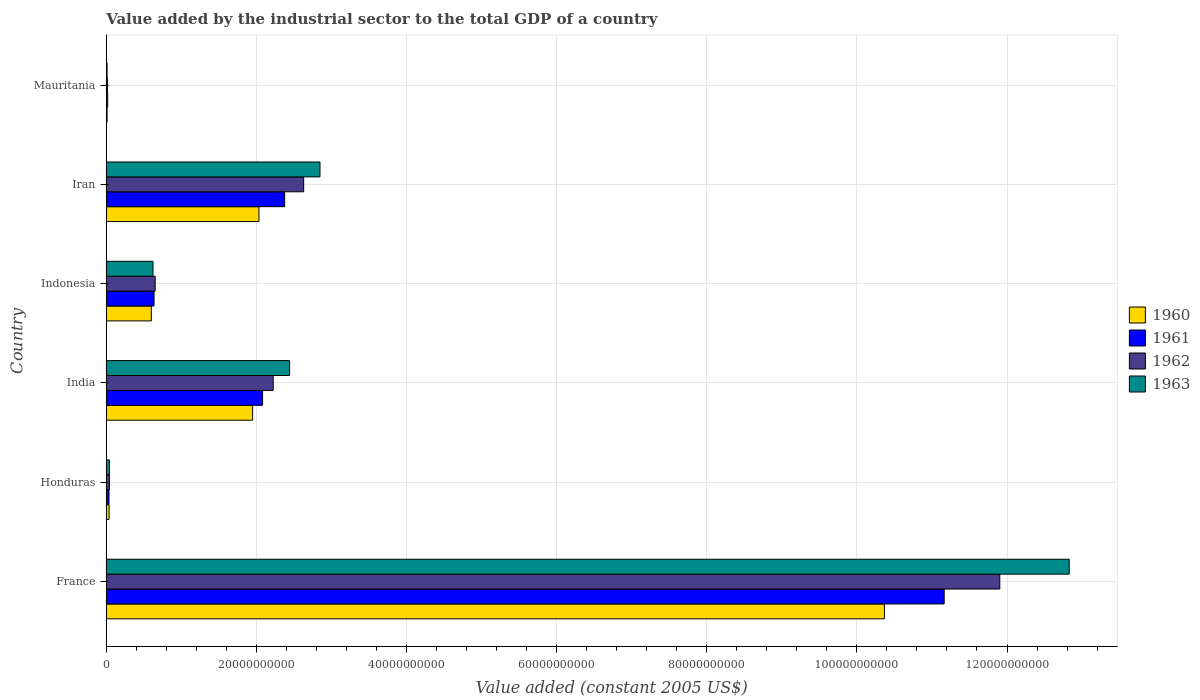Are the number of bars on each tick of the Y-axis equal?
Give a very brief answer. Yes. What is the label of the 2nd group of bars from the top?
Your answer should be very brief. Iran. What is the value added by the industrial sector in 1963 in Honduras?
Offer a terse response. 4.23e+08. Across all countries, what is the maximum value added by the industrial sector in 1963?
Give a very brief answer. 1.28e+11. Across all countries, what is the minimum value added by the industrial sector in 1961?
Offer a terse response. 1.92e+08. In which country was the value added by the industrial sector in 1963 minimum?
Make the answer very short. Mauritania. What is the total value added by the industrial sector in 1963 in the graph?
Ensure brevity in your answer.  1.88e+11. What is the difference between the value added by the industrial sector in 1963 in Honduras and that in Iran?
Offer a terse response. -2.81e+1. What is the difference between the value added by the industrial sector in 1963 in India and the value added by the industrial sector in 1960 in France?
Ensure brevity in your answer.  -7.92e+1. What is the average value added by the industrial sector in 1963 per country?
Your response must be concise. 3.13e+1. What is the difference between the value added by the industrial sector in 1962 and value added by the industrial sector in 1960 in Indonesia?
Offer a terse response. 5.10e+08. In how many countries, is the value added by the industrial sector in 1962 greater than 72000000000 US$?
Your answer should be compact. 1. What is the ratio of the value added by the industrial sector in 1963 in Honduras to that in Mauritania?
Your response must be concise. 3.91. Is the difference between the value added by the industrial sector in 1962 in France and India greater than the difference between the value added by the industrial sector in 1960 in France and India?
Make the answer very short. Yes. What is the difference between the highest and the second highest value added by the industrial sector in 1961?
Provide a succinct answer. 8.79e+1. What is the difference between the highest and the lowest value added by the industrial sector in 1960?
Offer a terse response. 1.04e+11. What does the 4th bar from the top in Iran represents?
Give a very brief answer. 1960. Are all the bars in the graph horizontal?
Provide a succinct answer. Yes. How many legend labels are there?
Provide a short and direct response. 4. What is the title of the graph?
Keep it short and to the point. Value added by the industrial sector to the total GDP of a country. What is the label or title of the X-axis?
Give a very brief answer. Value added (constant 2005 US$). What is the Value added (constant 2005 US$) in 1960 in France?
Offer a terse response. 1.04e+11. What is the Value added (constant 2005 US$) in 1961 in France?
Offer a terse response. 1.12e+11. What is the Value added (constant 2005 US$) of 1962 in France?
Keep it short and to the point. 1.19e+11. What is the Value added (constant 2005 US$) of 1963 in France?
Keep it short and to the point. 1.28e+11. What is the Value added (constant 2005 US$) in 1960 in Honduras?
Provide a succinct answer. 3.75e+08. What is the Value added (constant 2005 US$) in 1961 in Honduras?
Ensure brevity in your answer.  3.66e+08. What is the Value added (constant 2005 US$) in 1962 in Honduras?
Keep it short and to the point. 4.16e+08. What is the Value added (constant 2005 US$) of 1963 in Honduras?
Give a very brief answer. 4.23e+08. What is the Value added (constant 2005 US$) of 1960 in India?
Keep it short and to the point. 1.95e+1. What is the Value added (constant 2005 US$) in 1961 in India?
Your response must be concise. 2.08e+1. What is the Value added (constant 2005 US$) of 1962 in India?
Your response must be concise. 2.22e+1. What is the Value added (constant 2005 US$) in 1963 in India?
Make the answer very short. 2.44e+1. What is the Value added (constant 2005 US$) in 1960 in Indonesia?
Your response must be concise. 6.01e+09. What is the Value added (constant 2005 US$) of 1961 in Indonesia?
Provide a short and direct response. 6.37e+09. What is the Value added (constant 2005 US$) in 1962 in Indonesia?
Make the answer very short. 6.52e+09. What is the Value added (constant 2005 US$) of 1963 in Indonesia?
Make the answer very short. 6.23e+09. What is the Value added (constant 2005 US$) of 1960 in Iran?
Provide a short and direct response. 2.03e+1. What is the Value added (constant 2005 US$) of 1961 in Iran?
Keep it short and to the point. 2.38e+1. What is the Value added (constant 2005 US$) in 1962 in Iran?
Offer a terse response. 2.63e+1. What is the Value added (constant 2005 US$) of 1963 in Iran?
Make the answer very short. 2.85e+1. What is the Value added (constant 2005 US$) of 1960 in Mauritania?
Ensure brevity in your answer.  1.15e+08. What is the Value added (constant 2005 US$) of 1961 in Mauritania?
Your answer should be very brief. 1.92e+08. What is the Value added (constant 2005 US$) of 1962 in Mauritania?
Ensure brevity in your answer.  1.51e+08. What is the Value added (constant 2005 US$) in 1963 in Mauritania?
Your response must be concise. 1.08e+08. Across all countries, what is the maximum Value added (constant 2005 US$) of 1960?
Your answer should be compact. 1.04e+11. Across all countries, what is the maximum Value added (constant 2005 US$) of 1961?
Your answer should be very brief. 1.12e+11. Across all countries, what is the maximum Value added (constant 2005 US$) in 1962?
Provide a succinct answer. 1.19e+11. Across all countries, what is the maximum Value added (constant 2005 US$) of 1963?
Your answer should be very brief. 1.28e+11. Across all countries, what is the minimum Value added (constant 2005 US$) of 1960?
Provide a succinct answer. 1.15e+08. Across all countries, what is the minimum Value added (constant 2005 US$) of 1961?
Keep it short and to the point. 1.92e+08. Across all countries, what is the minimum Value added (constant 2005 US$) of 1962?
Your response must be concise. 1.51e+08. Across all countries, what is the minimum Value added (constant 2005 US$) of 1963?
Offer a terse response. 1.08e+08. What is the total Value added (constant 2005 US$) in 1960 in the graph?
Provide a succinct answer. 1.50e+11. What is the total Value added (constant 2005 US$) in 1961 in the graph?
Provide a short and direct response. 1.63e+11. What is the total Value added (constant 2005 US$) of 1962 in the graph?
Make the answer very short. 1.75e+11. What is the total Value added (constant 2005 US$) in 1963 in the graph?
Offer a terse response. 1.88e+11. What is the difference between the Value added (constant 2005 US$) in 1960 in France and that in Honduras?
Make the answer very short. 1.03e+11. What is the difference between the Value added (constant 2005 US$) of 1961 in France and that in Honduras?
Your response must be concise. 1.11e+11. What is the difference between the Value added (constant 2005 US$) of 1962 in France and that in Honduras?
Your answer should be compact. 1.19e+11. What is the difference between the Value added (constant 2005 US$) in 1963 in France and that in Honduras?
Your answer should be compact. 1.28e+11. What is the difference between the Value added (constant 2005 US$) of 1960 in France and that in India?
Make the answer very short. 8.42e+1. What is the difference between the Value added (constant 2005 US$) of 1961 in France and that in India?
Your response must be concise. 9.08e+1. What is the difference between the Value added (constant 2005 US$) in 1962 in France and that in India?
Your answer should be very brief. 9.68e+1. What is the difference between the Value added (constant 2005 US$) in 1963 in France and that in India?
Provide a succinct answer. 1.04e+11. What is the difference between the Value added (constant 2005 US$) in 1960 in France and that in Indonesia?
Offer a terse response. 9.77e+1. What is the difference between the Value added (constant 2005 US$) in 1961 in France and that in Indonesia?
Provide a short and direct response. 1.05e+11. What is the difference between the Value added (constant 2005 US$) of 1962 in France and that in Indonesia?
Give a very brief answer. 1.13e+11. What is the difference between the Value added (constant 2005 US$) in 1963 in France and that in Indonesia?
Provide a succinct answer. 1.22e+11. What is the difference between the Value added (constant 2005 US$) of 1960 in France and that in Iran?
Give a very brief answer. 8.33e+1. What is the difference between the Value added (constant 2005 US$) in 1961 in France and that in Iran?
Make the answer very short. 8.79e+1. What is the difference between the Value added (constant 2005 US$) in 1962 in France and that in Iran?
Your response must be concise. 9.27e+1. What is the difference between the Value added (constant 2005 US$) in 1963 in France and that in Iran?
Ensure brevity in your answer.  9.98e+1. What is the difference between the Value added (constant 2005 US$) of 1960 in France and that in Mauritania?
Your answer should be very brief. 1.04e+11. What is the difference between the Value added (constant 2005 US$) in 1961 in France and that in Mauritania?
Give a very brief answer. 1.11e+11. What is the difference between the Value added (constant 2005 US$) of 1962 in France and that in Mauritania?
Your response must be concise. 1.19e+11. What is the difference between the Value added (constant 2005 US$) of 1963 in France and that in Mauritania?
Your response must be concise. 1.28e+11. What is the difference between the Value added (constant 2005 US$) in 1960 in Honduras and that in India?
Make the answer very short. -1.91e+1. What is the difference between the Value added (constant 2005 US$) of 1961 in Honduras and that in India?
Give a very brief answer. -2.05e+1. What is the difference between the Value added (constant 2005 US$) in 1962 in Honduras and that in India?
Provide a short and direct response. -2.18e+1. What is the difference between the Value added (constant 2005 US$) of 1963 in Honduras and that in India?
Keep it short and to the point. -2.40e+1. What is the difference between the Value added (constant 2005 US$) in 1960 in Honduras and that in Indonesia?
Make the answer very short. -5.63e+09. What is the difference between the Value added (constant 2005 US$) of 1961 in Honduras and that in Indonesia?
Offer a terse response. -6.00e+09. What is the difference between the Value added (constant 2005 US$) in 1962 in Honduras and that in Indonesia?
Make the answer very short. -6.10e+09. What is the difference between the Value added (constant 2005 US$) of 1963 in Honduras and that in Indonesia?
Give a very brief answer. -5.81e+09. What is the difference between the Value added (constant 2005 US$) in 1960 in Honduras and that in Iran?
Provide a short and direct response. -2.00e+1. What is the difference between the Value added (constant 2005 US$) in 1961 in Honduras and that in Iran?
Provide a succinct answer. -2.34e+1. What is the difference between the Value added (constant 2005 US$) of 1962 in Honduras and that in Iran?
Keep it short and to the point. -2.59e+1. What is the difference between the Value added (constant 2005 US$) in 1963 in Honduras and that in Iran?
Provide a short and direct response. -2.81e+1. What is the difference between the Value added (constant 2005 US$) of 1960 in Honduras and that in Mauritania?
Ensure brevity in your answer.  2.60e+08. What is the difference between the Value added (constant 2005 US$) of 1961 in Honduras and that in Mauritania?
Provide a succinct answer. 1.74e+08. What is the difference between the Value added (constant 2005 US$) of 1962 in Honduras and that in Mauritania?
Ensure brevity in your answer.  2.65e+08. What is the difference between the Value added (constant 2005 US$) of 1963 in Honduras and that in Mauritania?
Your answer should be compact. 3.15e+08. What is the difference between the Value added (constant 2005 US$) of 1960 in India and that in Indonesia?
Offer a very short reply. 1.35e+1. What is the difference between the Value added (constant 2005 US$) of 1961 in India and that in Indonesia?
Make the answer very short. 1.45e+1. What is the difference between the Value added (constant 2005 US$) in 1962 in India and that in Indonesia?
Give a very brief answer. 1.57e+1. What is the difference between the Value added (constant 2005 US$) in 1963 in India and that in Indonesia?
Your response must be concise. 1.82e+1. What is the difference between the Value added (constant 2005 US$) in 1960 in India and that in Iran?
Ensure brevity in your answer.  -8.36e+08. What is the difference between the Value added (constant 2005 US$) of 1961 in India and that in Iran?
Give a very brief answer. -2.94e+09. What is the difference between the Value added (constant 2005 US$) of 1962 in India and that in Iran?
Your answer should be compact. -4.06e+09. What is the difference between the Value added (constant 2005 US$) in 1963 in India and that in Iran?
Offer a very short reply. -4.05e+09. What is the difference between the Value added (constant 2005 US$) in 1960 in India and that in Mauritania?
Your answer should be very brief. 1.94e+1. What is the difference between the Value added (constant 2005 US$) in 1961 in India and that in Mauritania?
Provide a succinct answer. 2.06e+1. What is the difference between the Value added (constant 2005 US$) in 1962 in India and that in Mauritania?
Your response must be concise. 2.21e+1. What is the difference between the Value added (constant 2005 US$) in 1963 in India and that in Mauritania?
Ensure brevity in your answer.  2.43e+1. What is the difference between the Value added (constant 2005 US$) of 1960 in Indonesia and that in Iran?
Give a very brief answer. -1.43e+1. What is the difference between the Value added (constant 2005 US$) of 1961 in Indonesia and that in Iran?
Ensure brevity in your answer.  -1.74e+1. What is the difference between the Value added (constant 2005 US$) of 1962 in Indonesia and that in Iran?
Keep it short and to the point. -1.98e+1. What is the difference between the Value added (constant 2005 US$) in 1963 in Indonesia and that in Iran?
Your answer should be very brief. -2.22e+1. What is the difference between the Value added (constant 2005 US$) in 1960 in Indonesia and that in Mauritania?
Keep it short and to the point. 5.89e+09. What is the difference between the Value added (constant 2005 US$) of 1961 in Indonesia and that in Mauritania?
Offer a terse response. 6.17e+09. What is the difference between the Value added (constant 2005 US$) in 1962 in Indonesia and that in Mauritania?
Make the answer very short. 6.37e+09. What is the difference between the Value added (constant 2005 US$) in 1963 in Indonesia and that in Mauritania?
Give a very brief answer. 6.12e+09. What is the difference between the Value added (constant 2005 US$) in 1960 in Iran and that in Mauritania?
Your answer should be very brief. 2.02e+1. What is the difference between the Value added (constant 2005 US$) of 1961 in Iran and that in Mauritania?
Your answer should be compact. 2.36e+1. What is the difference between the Value added (constant 2005 US$) of 1962 in Iran and that in Mauritania?
Offer a very short reply. 2.62e+1. What is the difference between the Value added (constant 2005 US$) of 1963 in Iran and that in Mauritania?
Provide a succinct answer. 2.84e+1. What is the difference between the Value added (constant 2005 US$) in 1960 in France and the Value added (constant 2005 US$) in 1961 in Honduras?
Offer a terse response. 1.03e+11. What is the difference between the Value added (constant 2005 US$) in 1960 in France and the Value added (constant 2005 US$) in 1962 in Honduras?
Offer a terse response. 1.03e+11. What is the difference between the Value added (constant 2005 US$) of 1960 in France and the Value added (constant 2005 US$) of 1963 in Honduras?
Your answer should be compact. 1.03e+11. What is the difference between the Value added (constant 2005 US$) in 1961 in France and the Value added (constant 2005 US$) in 1962 in Honduras?
Ensure brevity in your answer.  1.11e+11. What is the difference between the Value added (constant 2005 US$) of 1961 in France and the Value added (constant 2005 US$) of 1963 in Honduras?
Your answer should be compact. 1.11e+11. What is the difference between the Value added (constant 2005 US$) in 1962 in France and the Value added (constant 2005 US$) in 1963 in Honduras?
Keep it short and to the point. 1.19e+11. What is the difference between the Value added (constant 2005 US$) in 1960 in France and the Value added (constant 2005 US$) in 1961 in India?
Offer a terse response. 8.28e+1. What is the difference between the Value added (constant 2005 US$) of 1960 in France and the Value added (constant 2005 US$) of 1962 in India?
Your response must be concise. 8.14e+1. What is the difference between the Value added (constant 2005 US$) in 1960 in France and the Value added (constant 2005 US$) in 1963 in India?
Provide a short and direct response. 7.92e+1. What is the difference between the Value added (constant 2005 US$) of 1961 in France and the Value added (constant 2005 US$) of 1962 in India?
Offer a terse response. 8.94e+1. What is the difference between the Value added (constant 2005 US$) in 1961 in France and the Value added (constant 2005 US$) in 1963 in India?
Provide a succinct answer. 8.72e+1. What is the difference between the Value added (constant 2005 US$) in 1962 in France and the Value added (constant 2005 US$) in 1963 in India?
Provide a short and direct response. 9.46e+1. What is the difference between the Value added (constant 2005 US$) in 1960 in France and the Value added (constant 2005 US$) in 1961 in Indonesia?
Ensure brevity in your answer.  9.73e+1. What is the difference between the Value added (constant 2005 US$) of 1960 in France and the Value added (constant 2005 US$) of 1962 in Indonesia?
Keep it short and to the point. 9.71e+1. What is the difference between the Value added (constant 2005 US$) in 1960 in France and the Value added (constant 2005 US$) in 1963 in Indonesia?
Your answer should be very brief. 9.74e+1. What is the difference between the Value added (constant 2005 US$) in 1961 in France and the Value added (constant 2005 US$) in 1962 in Indonesia?
Your answer should be compact. 1.05e+11. What is the difference between the Value added (constant 2005 US$) in 1961 in France and the Value added (constant 2005 US$) in 1963 in Indonesia?
Offer a terse response. 1.05e+11. What is the difference between the Value added (constant 2005 US$) in 1962 in France and the Value added (constant 2005 US$) in 1963 in Indonesia?
Provide a succinct answer. 1.13e+11. What is the difference between the Value added (constant 2005 US$) in 1960 in France and the Value added (constant 2005 US$) in 1961 in Iran?
Provide a succinct answer. 7.99e+1. What is the difference between the Value added (constant 2005 US$) of 1960 in France and the Value added (constant 2005 US$) of 1962 in Iran?
Provide a succinct answer. 7.74e+1. What is the difference between the Value added (constant 2005 US$) of 1960 in France and the Value added (constant 2005 US$) of 1963 in Iran?
Provide a succinct answer. 7.52e+1. What is the difference between the Value added (constant 2005 US$) of 1961 in France and the Value added (constant 2005 US$) of 1962 in Iran?
Ensure brevity in your answer.  8.53e+1. What is the difference between the Value added (constant 2005 US$) of 1961 in France and the Value added (constant 2005 US$) of 1963 in Iran?
Your answer should be compact. 8.32e+1. What is the difference between the Value added (constant 2005 US$) of 1962 in France and the Value added (constant 2005 US$) of 1963 in Iran?
Your response must be concise. 9.06e+1. What is the difference between the Value added (constant 2005 US$) of 1960 in France and the Value added (constant 2005 US$) of 1961 in Mauritania?
Your answer should be compact. 1.03e+11. What is the difference between the Value added (constant 2005 US$) of 1960 in France and the Value added (constant 2005 US$) of 1962 in Mauritania?
Offer a terse response. 1.04e+11. What is the difference between the Value added (constant 2005 US$) in 1960 in France and the Value added (constant 2005 US$) in 1963 in Mauritania?
Offer a very short reply. 1.04e+11. What is the difference between the Value added (constant 2005 US$) of 1961 in France and the Value added (constant 2005 US$) of 1962 in Mauritania?
Provide a succinct answer. 1.11e+11. What is the difference between the Value added (constant 2005 US$) in 1961 in France and the Value added (constant 2005 US$) in 1963 in Mauritania?
Your response must be concise. 1.12e+11. What is the difference between the Value added (constant 2005 US$) of 1962 in France and the Value added (constant 2005 US$) of 1963 in Mauritania?
Provide a short and direct response. 1.19e+11. What is the difference between the Value added (constant 2005 US$) in 1960 in Honduras and the Value added (constant 2005 US$) in 1961 in India?
Make the answer very short. -2.05e+1. What is the difference between the Value added (constant 2005 US$) of 1960 in Honduras and the Value added (constant 2005 US$) of 1962 in India?
Provide a short and direct response. -2.19e+1. What is the difference between the Value added (constant 2005 US$) of 1960 in Honduras and the Value added (constant 2005 US$) of 1963 in India?
Make the answer very short. -2.41e+1. What is the difference between the Value added (constant 2005 US$) in 1961 in Honduras and the Value added (constant 2005 US$) in 1962 in India?
Offer a very short reply. -2.19e+1. What is the difference between the Value added (constant 2005 US$) of 1961 in Honduras and the Value added (constant 2005 US$) of 1963 in India?
Offer a terse response. -2.41e+1. What is the difference between the Value added (constant 2005 US$) of 1962 in Honduras and the Value added (constant 2005 US$) of 1963 in India?
Ensure brevity in your answer.  -2.40e+1. What is the difference between the Value added (constant 2005 US$) of 1960 in Honduras and the Value added (constant 2005 US$) of 1961 in Indonesia?
Offer a very short reply. -5.99e+09. What is the difference between the Value added (constant 2005 US$) in 1960 in Honduras and the Value added (constant 2005 US$) in 1962 in Indonesia?
Your answer should be very brief. -6.14e+09. What is the difference between the Value added (constant 2005 US$) of 1960 in Honduras and the Value added (constant 2005 US$) of 1963 in Indonesia?
Offer a very short reply. -5.85e+09. What is the difference between the Value added (constant 2005 US$) in 1961 in Honduras and the Value added (constant 2005 US$) in 1962 in Indonesia?
Your response must be concise. -6.15e+09. What is the difference between the Value added (constant 2005 US$) of 1961 in Honduras and the Value added (constant 2005 US$) of 1963 in Indonesia?
Offer a terse response. -5.86e+09. What is the difference between the Value added (constant 2005 US$) in 1962 in Honduras and the Value added (constant 2005 US$) in 1963 in Indonesia?
Offer a very short reply. -5.81e+09. What is the difference between the Value added (constant 2005 US$) of 1960 in Honduras and the Value added (constant 2005 US$) of 1961 in Iran?
Your response must be concise. -2.34e+1. What is the difference between the Value added (constant 2005 US$) in 1960 in Honduras and the Value added (constant 2005 US$) in 1962 in Iran?
Give a very brief answer. -2.59e+1. What is the difference between the Value added (constant 2005 US$) in 1960 in Honduras and the Value added (constant 2005 US$) in 1963 in Iran?
Give a very brief answer. -2.81e+1. What is the difference between the Value added (constant 2005 US$) in 1961 in Honduras and the Value added (constant 2005 US$) in 1962 in Iran?
Give a very brief answer. -2.59e+1. What is the difference between the Value added (constant 2005 US$) of 1961 in Honduras and the Value added (constant 2005 US$) of 1963 in Iran?
Keep it short and to the point. -2.81e+1. What is the difference between the Value added (constant 2005 US$) of 1962 in Honduras and the Value added (constant 2005 US$) of 1963 in Iran?
Ensure brevity in your answer.  -2.81e+1. What is the difference between the Value added (constant 2005 US$) of 1960 in Honduras and the Value added (constant 2005 US$) of 1961 in Mauritania?
Make the answer very short. 1.83e+08. What is the difference between the Value added (constant 2005 US$) of 1960 in Honduras and the Value added (constant 2005 US$) of 1962 in Mauritania?
Provide a short and direct response. 2.24e+08. What is the difference between the Value added (constant 2005 US$) of 1960 in Honduras and the Value added (constant 2005 US$) of 1963 in Mauritania?
Your response must be concise. 2.67e+08. What is the difference between the Value added (constant 2005 US$) in 1961 in Honduras and the Value added (constant 2005 US$) in 1962 in Mauritania?
Provide a succinct answer. 2.15e+08. What is the difference between the Value added (constant 2005 US$) of 1961 in Honduras and the Value added (constant 2005 US$) of 1963 in Mauritania?
Keep it short and to the point. 2.58e+08. What is the difference between the Value added (constant 2005 US$) in 1962 in Honduras and the Value added (constant 2005 US$) in 1963 in Mauritania?
Your answer should be very brief. 3.08e+08. What is the difference between the Value added (constant 2005 US$) of 1960 in India and the Value added (constant 2005 US$) of 1961 in Indonesia?
Give a very brief answer. 1.31e+1. What is the difference between the Value added (constant 2005 US$) of 1960 in India and the Value added (constant 2005 US$) of 1962 in Indonesia?
Your answer should be compact. 1.30e+1. What is the difference between the Value added (constant 2005 US$) of 1960 in India and the Value added (constant 2005 US$) of 1963 in Indonesia?
Give a very brief answer. 1.33e+1. What is the difference between the Value added (constant 2005 US$) of 1961 in India and the Value added (constant 2005 US$) of 1962 in Indonesia?
Make the answer very short. 1.43e+1. What is the difference between the Value added (constant 2005 US$) in 1961 in India and the Value added (constant 2005 US$) in 1963 in Indonesia?
Offer a terse response. 1.46e+1. What is the difference between the Value added (constant 2005 US$) of 1962 in India and the Value added (constant 2005 US$) of 1963 in Indonesia?
Provide a short and direct response. 1.60e+1. What is the difference between the Value added (constant 2005 US$) in 1960 in India and the Value added (constant 2005 US$) in 1961 in Iran?
Offer a terse response. -4.27e+09. What is the difference between the Value added (constant 2005 US$) in 1960 in India and the Value added (constant 2005 US$) in 1962 in Iran?
Provide a succinct answer. -6.80e+09. What is the difference between the Value added (constant 2005 US$) of 1960 in India and the Value added (constant 2005 US$) of 1963 in Iran?
Offer a terse response. -8.97e+09. What is the difference between the Value added (constant 2005 US$) of 1961 in India and the Value added (constant 2005 US$) of 1962 in Iran?
Make the answer very short. -5.48e+09. What is the difference between the Value added (constant 2005 US$) of 1961 in India and the Value added (constant 2005 US$) of 1963 in Iran?
Your answer should be compact. -7.65e+09. What is the difference between the Value added (constant 2005 US$) of 1962 in India and the Value added (constant 2005 US$) of 1963 in Iran?
Make the answer very short. -6.23e+09. What is the difference between the Value added (constant 2005 US$) in 1960 in India and the Value added (constant 2005 US$) in 1961 in Mauritania?
Provide a succinct answer. 1.93e+1. What is the difference between the Value added (constant 2005 US$) in 1960 in India and the Value added (constant 2005 US$) in 1962 in Mauritania?
Keep it short and to the point. 1.94e+1. What is the difference between the Value added (constant 2005 US$) in 1960 in India and the Value added (constant 2005 US$) in 1963 in Mauritania?
Offer a terse response. 1.94e+1. What is the difference between the Value added (constant 2005 US$) in 1961 in India and the Value added (constant 2005 US$) in 1962 in Mauritania?
Your response must be concise. 2.07e+1. What is the difference between the Value added (constant 2005 US$) in 1961 in India and the Value added (constant 2005 US$) in 1963 in Mauritania?
Your answer should be very brief. 2.07e+1. What is the difference between the Value added (constant 2005 US$) of 1962 in India and the Value added (constant 2005 US$) of 1963 in Mauritania?
Your response must be concise. 2.21e+1. What is the difference between the Value added (constant 2005 US$) of 1960 in Indonesia and the Value added (constant 2005 US$) of 1961 in Iran?
Ensure brevity in your answer.  -1.78e+1. What is the difference between the Value added (constant 2005 US$) in 1960 in Indonesia and the Value added (constant 2005 US$) in 1962 in Iran?
Offer a very short reply. -2.03e+1. What is the difference between the Value added (constant 2005 US$) of 1960 in Indonesia and the Value added (constant 2005 US$) of 1963 in Iran?
Ensure brevity in your answer.  -2.25e+1. What is the difference between the Value added (constant 2005 US$) of 1961 in Indonesia and the Value added (constant 2005 US$) of 1962 in Iran?
Make the answer very short. -1.99e+1. What is the difference between the Value added (constant 2005 US$) of 1961 in Indonesia and the Value added (constant 2005 US$) of 1963 in Iran?
Offer a very short reply. -2.21e+1. What is the difference between the Value added (constant 2005 US$) of 1962 in Indonesia and the Value added (constant 2005 US$) of 1963 in Iran?
Offer a very short reply. -2.20e+1. What is the difference between the Value added (constant 2005 US$) in 1960 in Indonesia and the Value added (constant 2005 US$) in 1961 in Mauritania?
Offer a terse response. 5.81e+09. What is the difference between the Value added (constant 2005 US$) in 1960 in Indonesia and the Value added (constant 2005 US$) in 1962 in Mauritania?
Your answer should be very brief. 5.86e+09. What is the difference between the Value added (constant 2005 US$) of 1960 in Indonesia and the Value added (constant 2005 US$) of 1963 in Mauritania?
Provide a short and direct response. 5.90e+09. What is the difference between the Value added (constant 2005 US$) of 1961 in Indonesia and the Value added (constant 2005 US$) of 1962 in Mauritania?
Offer a very short reply. 6.22e+09. What is the difference between the Value added (constant 2005 US$) in 1961 in Indonesia and the Value added (constant 2005 US$) in 1963 in Mauritania?
Your response must be concise. 6.26e+09. What is the difference between the Value added (constant 2005 US$) in 1962 in Indonesia and the Value added (constant 2005 US$) in 1963 in Mauritania?
Provide a succinct answer. 6.41e+09. What is the difference between the Value added (constant 2005 US$) of 1960 in Iran and the Value added (constant 2005 US$) of 1961 in Mauritania?
Provide a succinct answer. 2.01e+1. What is the difference between the Value added (constant 2005 US$) of 1960 in Iran and the Value added (constant 2005 US$) of 1962 in Mauritania?
Offer a terse response. 2.02e+1. What is the difference between the Value added (constant 2005 US$) in 1960 in Iran and the Value added (constant 2005 US$) in 1963 in Mauritania?
Your answer should be compact. 2.02e+1. What is the difference between the Value added (constant 2005 US$) of 1961 in Iran and the Value added (constant 2005 US$) of 1962 in Mauritania?
Offer a very short reply. 2.36e+1. What is the difference between the Value added (constant 2005 US$) in 1961 in Iran and the Value added (constant 2005 US$) in 1963 in Mauritania?
Offer a very short reply. 2.37e+1. What is the difference between the Value added (constant 2005 US$) of 1962 in Iran and the Value added (constant 2005 US$) of 1963 in Mauritania?
Your answer should be very brief. 2.62e+1. What is the average Value added (constant 2005 US$) of 1960 per country?
Give a very brief answer. 2.50e+1. What is the average Value added (constant 2005 US$) of 1961 per country?
Ensure brevity in your answer.  2.72e+1. What is the average Value added (constant 2005 US$) of 1962 per country?
Make the answer very short. 2.91e+1. What is the average Value added (constant 2005 US$) in 1963 per country?
Give a very brief answer. 3.13e+1. What is the difference between the Value added (constant 2005 US$) in 1960 and Value added (constant 2005 US$) in 1961 in France?
Keep it short and to the point. -7.97e+09. What is the difference between the Value added (constant 2005 US$) of 1960 and Value added (constant 2005 US$) of 1962 in France?
Your answer should be compact. -1.54e+1. What is the difference between the Value added (constant 2005 US$) of 1960 and Value added (constant 2005 US$) of 1963 in France?
Offer a terse response. -2.46e+1. What is the difference between the Value added (constant 2005 US$) in 1961 and Value added (constant 2005 US$) in 1962 in France?
Your answer should be compact. -7.41e+09. What is the difference between the Value added (constant 2005 US$) in 1961 and Value added (constant 2005 US$) in 1963 in France?
Offer a very short reply. -1.67e+1. What is the difference between the Value added (constant 2005 US$) in 1962 and Value added (constant 2005 US$) in 1963 in France?
Make the answer very short. -9.25e+09. What is the difference between the Value added (constant 2005 US$) in 1960 and Value added (constant 2005 US$) in 1961 in Honduras?
Offer a very short reply. 9.37e+06. What is the difference between the Value added (constant 2005 US$) of 1960 and Value added (constant 2005 US$) of 1962 in Honduras?
Keep it short and to the point. -4.07e+07. What is the difference between the Value added (constant 2005 US$) in 1960 and Value added (constant 2005 US$) in 1963 in Honduras?
Make the answer very short. -4.79e+07. What is the difference between the Value added (constant 2005 US$) of 1961 and Value added (constant 2005 US$) of 1962 in Honduras?
Give a very brief answer. -5.00e+07. What is the difference between the Value added (constant 2005 US$) in 1961 and Value added (constant 2005 US$) in 1963 in Honduras?
Your response must be concise. -5.72e+07. What is the difference between the Value added (constant 2005 US$) in 1962 and Value added (constant 2005 US$) in 1963 in Honduras?
Your response must be concise. -7.19e+06. What is the difference between the Value added (constant 2005 US$) of 1960 and Value added (constant 2005 US$) of 1961 in India?
Ensure brevity in your answer.  -1.32e+09. What is the difference between the Value added (constant 2005 US$) of 1960 and Value added (constant 2005 US$) of 1962 in India?
Give a very brief answer. -2.74e+09. What is the difference between the Value added (constant 2005 US$) in 1960 and Value added (constant 2005 US$) in 1963 in India?
Offer a terse response. -4.92e+09. What is the difference between the Value added (constant 2005 US$) in 1961 and Value added (constant 2005 US$) in 1962 in India?
Keep it short and to the point. -1.42e+09. What is the difference between the Value added (constant 2005 US$) of 1961 and Value added (constant 2005 US$) of 1963 in India?
Provide a short and direct response. -3.60e+09. What is the difference between the Value added (constant 2005 US$) in 1962 and Value added (constant 2005 US$) in 1963 in India?
Ensure brevity in your answer.  -2.18e+09. What is the difference between the Value added (constant 2005 US$) in 1960 and Value added (constant 2005 US$) in 1961 in Indonesia?
Provide a short and direct response. -3.60e+08. What is the difference between the Value added (constant 2005 US$) of 1960 and Value added (constant 2005 US$) of 1962 in Indonesia?
Provide a short and direct response. -5.10e+08. What is the difference between the Value added (constant 2005 US$) in 1960 and Value added (constant 2005 US$) in 1963 in Indonesia?
Make the answer very short. -2.22e+08. What is the difference between the Value added (constant 2005 US$) in 1961 and Value added (constant 2005 US$) in 1962 in Indonesia?
Keep it short and to the point. -1.50e+08. What is the difference between the Value added (constant 2005 US$) of 1961 and Value added (constant 2005 US$) of 1963 in Indonesia?
Your answer should be compact. 1.38e+08. What is the difference between the Value added (constant 2005 US$) in 1962 and Value added (constant 2005 US$) in 1963 in Indonesia?
Your answer should be compact. 2.88e+08. What is the difference between the Value added (constant 2005 US$) in 1960 and Value added (constant 2005 US$) in 1961 in Iran?
Offer a very short reply. -3.43e+09. What is the difference between the Value added (constant 2005 US$) of 1960 and Value added (constant 2005 US$) of 1962 in Iran?
Offer a very short reply. -5.96e+09. What is the difference between the Value added (constant 2005 US$) of 1960 and Value added (constant 2005 US$) of 1963 in Iran?
Provide a succinct answer. -8.14e+09. What is the difference between the Value added (constant 2005 US$) of 1961 and Value added (constant 2005 US$) of 1962 in Iran?
Ensure brevity in your answer.  -2.53e+09. What is the difference between the Value added (constant 2005 US$) of 1961 and Value added (constant 2005 US$) of 1963 in Iran?
Make the answer very short. -4.71e+09. What is the difference between the Value added (constant 2005 US$) in 1962 and Value added (constant 2005 US$) in 1963 in Iran?
Your response must be concise. -2.17e+09. What is the difference between the Value added (constant 2005 US$) of 1960 and Value added (constant 2005 US$) of 1961 in Mauritania?
Your answer should be compact. -7.68e+07. What is the difference between the Value added (constant 2005 US$) of 1960 and Value added (constant 2005 US$) of 1962 in Mauritania?
Offer a very short reply. -3.59e+07. What is the difference between the Value added (constant 2005 US$) in 1960 and Value added (constant 2005 US$) in 1963 in Mauritania?
Your answer should be compact. 7.13e+06. What is the difference between the Value added (constant 2005 US$) of 1961 and Value added (constant 2005 US$) of 1962 in Mauritania?
Give a very brief answer. 4.09e+07. What is the difference between the Value added (constant 2005 US$) of 1961 and Value added (constant 2005 US$) of 1963 in Mauritania?
Offer a terse response. 8.39e+07. What is the difference between the Value added (constant 2005 US$) of 1962 and Value added (constant 2005 US$) of 1963 in Mauritania?
Keep it short and to the point. 4.31e+07. What is the ratio of the Value added (constant 2005 US$) of 1960 in France to that in Honduras?
Your response must be concise. 276.31. What is the ratio of the Value added (constant 2005 US$) in 1961 in France to that in Honduras?
Your response must be concise. 305.16. What is the ratio of the Value added (constant 2005 US$) in 1962 in France to that in Honduras?
Your answer should be compact. 286.26. What is the ratio of the Value added (constant 2005 US$) in 1963 in France to that in Honduras?
Your answer should be compact. 303.25. What is the ratio of the Value added (constant 2005 US$) of 1960 in France to that in India?
Offer a terse response. 5.32. What is the ratio of the Value added (constant 2005 US$) in 1961 in France to that in India?
Provide a succinct answer. 5.36. What is the ratio of the Value added (constant 2005 US$) of 1962 in France to that in India?
Give a very brief answer. 5.35. What is the ratio of the Value added (constant 2005 US$) of 1963 in France to that in India?
Your answer should be compact. 5.25. What is the ratio of the Value added (constant 2005 US$) of 1960 in France to that in Indonesia?
Your answer should be very brief. 17.26. What is the ratio of the Value added (constant 2005 US$) of 1961 in France to that in Indonesia?
Offer a very short reply. 17.53. What is the ratio of the Value added (constant 2005 US$) in 1962 in France to that in Indonesia?
Provide a succinct answer. 18.27. What is the ratio of the Value added (constant 2005 US$) in 1963 in France to that in Indonesia?
Your answer should be compact. 20.59. What is the ratio of the Value added (constant 2005 US$) in 1960 in France to that in Iran?
Your response must be concise. 5.1. What is the ratio of the Value added (constant 2005 US$) of 1961 in France to that in Iran?
Your answer should be compact. 4.7. What is the ratio of the Value added (constant 2005 US$) of 1962 in France to that in Iran?
Provide a short and direct response. 4.53. What is the ratio of the Value added (constant 2005 US$) in 1963 in France to that in Iran?
Provide a succinct answer. 4.51. What is the ratio of the Value added (constant 2005 US$) of 1960 in France to that in Mauritania?
Offer a very short reply. 898.65. What is the ratio of the Value added (constant 2005 US$) in 1961 in France to that in Mauritania?
Keep it short and to the point. 580.96. What is the ratio of the Value added (constant 2005 US$) of 1962 in France to that in Mauritania?
Give a very brief answer. 786.81. What is the ratio of the Value added (constant 2005 US$) of 1963 in France to that in Mauritania?
Give a very brief answer. 1185.36. What is the ratio of the Value added (constant 2005 US$) of 1960 in Honduras to that in India?
Keep it short and to the point. 0.02. What is the ratio of the Value added (constant 2005 US$) of 1961 in Honduras to that in India?
Make the answer very short. 0.02. What is the ratio of the Value added (constant 2005 US$) in 1962 in Honduras to that in India?
Keep it short and to the point. 0.02. What is the ratio of the Value added (constant 2005 US$) of 1963 in Honduras to that in India?
Ensure brevity in your answer.  0.02. What is the ratio of the Value added (constant 2005 US$) in 1960 in Honduras to that in Indonesia?
Give a very brief answer. 0.06. What is the ratio of the Value added (constant 2005 US$) of 1961 in Honduras to that in Indonesia?
Your response must be concise. 0.06. What is the ratio of the Value added (constant 2005 US$) in 1962 in Honduras to that in Indonesia?
Provide a succinct answer. 0.06. What is the ratio of the Value added (constant 2005 US$) of 1963 in Honduras to that in Indonesia?
Give a very brief answer. 0.07. What is the ratio of the Value added (constant 2005 US$) in 1960 in Honduras to that in Iran?
Give a very brief answer. 0.02. What is the ratio of the Value added (constant 2005 US$) in 1961 in Honduras to that in Iran?
Your answer should be compact. 0.02. What is the ratio of the Value added (constant 2005 US$) of 1962 in Honduras to that in Iran?
Provide a short and direct response. 0.02. What is the ratio of the Value added (constant 2005 US$) of 1963 in Honduras to that in Iran?
Provide a short and direct response. 0.01. What is the ratio of the Value added (constant 2005 US$) of 1960 in Honduras to that in Mauritania?
Your response must be concise. 3.25. What is the ratio of the Value added (constant 2005 US$) of 1961 in Honduras to that in Mauritania?
Offer a very short reply. 1.9. What is the ratio of the Value added (constant 2005 US$) of 1962 in Honduras to that in Mauritania?
Offer a terse response. 2.75. What is the ratio of the Value added (constant 2005 US$) in 1963 in Honduras to that in Mauritania?
Your answer should be very brief. 3.91. What is the ratio of the Value added (constant 2005 US$) of 1960 in India to that in Indonesia?
Offer a terse response. 3.25. What is the ratio of the Value added (constant 2005 US$) in 1961 in India to that in Indonesia?
Provide a short and direct response. 3.27. What is the ratio of the Value added (constant 2005 US$) of 1962 in India to that in Indonesia?
Give a very brief answer. 3.41. What is the ratio of the Value added (constant 2005 US$) of 1963 in India to that in Indonesia?
Make the answer very short. 3.92. What is the ratio of the Value added (constant 2005 US$) of 1960 in India to that in Iran?
Keep it short and to the point. 0.96. What is the ratio of the Value added (constant 2005 US$) of 1961 in India to that in Iran?
Make the answer very short. 0.88. What is the ratio of the Value added (constant 2005 US$) in 1962 in India to that in Iran?
Provide a succinct answer. 0.85. What is the ratio of the Value added (constant 2005 US$) of 1963 in India to that in Iran?
Make the answer very short. 0.86. What is the ratio of the Value added (constant 2005 US$) in 1960 in India to that in Mauritania?
Your answer should be very brief. 169.07. What is the ratio of the Value added (constant 2005 US$) of 1961 in India to that in Mauritania?
Offer a very short reply. 108.39. What is the ratio of the Value added (constant 2005 US$) of 1962 in India to that in Mauritania?
Offer a very short reply. 147.02. What is the ratio of the Value added (constant 2005 US$) of 1963 in India to that in Mauritania?
Provide a succinct answer. 225.7. What is the ratio of the Value added (constant 2005 US$) of 1960 in Indonesia to that in Iran?
Your answer should be compact. 0.3. What is the ratio of the Value added (constant 2005 US$) in 1961 in Indonesia to that in Iran?
Keep it short and to the point. 0.27. What is the ratio of the Value added (constant 2005 US$) in 1962 in Indonesia to that in Iran?
Keep it short and to the point. 0.25. What is the ratio of the Value added (constant 2005 US$) in 1963 in Indonesia to that in Iran?
Provide a short and direct response. 0.22. What is the ratio of the Value added (constant 2005 US$) in 1960 in Indonesia to that in Mauritania?
Offer a very short reply. 52.07. What is the ratio of the Value added (constant 2005 US$) of 1961 in Indonesia to that in Mauritania?
Your response must be concise. 33.14. What is the ratio of the Value added (constant 2005 US$) of 1962 in Indonesia to that in Mauritania?
Offer a terse response. 43.07. What is the ratio of the Value added (constant 2005 US$) of 1963 in Indonesia to that in Mauritania?
Make the answer very short. 57.56. What is the ratio of the Value added (constant 2005 US$) in 1960 in Iran to that in Mauritania?
Offer a very short reply. 176.32. What is the ratio of the Value added (constant 2005 US$) of 1961 in Iran to that in Mauritania?
Offer a very short reply. 123.7. What is the ratio of the Value added (constant 2005 US$) in 1962 in Iran to that in Mauritania?
Your answer should be compact. 173.84. What is the ratio of the Value added (constant 2005 US$) in 1963 in Iran to that in Mauritania?
Your answer should be very brief. 263.11. What is the difference between the highest and the second highest Value added (constant 2005 US$) in 1960?
Your response must be concise. 8.33e+1. What is the difference between the highest and the second highest Value added (constant 2005 US$) in 1961?
Offer a very short reply. 8.79e+1. What is the difference between the highest and the second highest Value added (constant 2005 US$) in 1962?
Give a very brief answer. 9.27e+1. What is the difference between the highest and the second highest Value added (constant 2005 US$) of 1963?
Offer a terse response. 9.98e+1. What is the difference between the highest and the lowest Value added (constant 2005 US$) of 1960?
Your answer should be compact. 1.04e+11. What is the difference between the highest and the lowest Value added (constant 2005 US$) in 1961?
Your answer should be compact. 1.11e+11. What is the difference between the highest and the lowest Value added (constant 2005 US$) in 1962?
Your answer should be very brief. 1.19e+11. What is the difference between the highest and the lowest Value added (constant 2005 US$) in 1963?
Ensure brevity in your answer.  1.28e+11. 